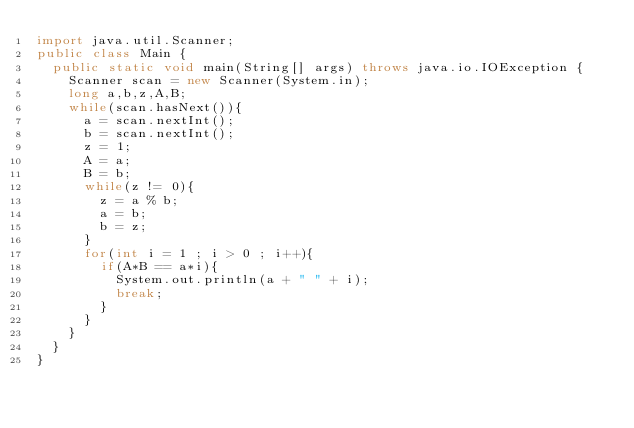<code> <loc_0><loc_0><loc_500><loc_500><_Java_>import java.util.Scanner;
public class Main {
	public static void main(String[] args) throws java.io.IOException {
		Scanner scan = new Scanner(System.in);
		long a,b,z,A,B;
		while(scan.hasNext()){
			a = scan.nextInt();
			b = scan.nextInt();
			z = 1;
			A = a;
			B = b;
			while(z != 0){
				z = a % b;
				a = b;
				b = z;
			}
			for(int i = 1 ; i > 0 ; i++){
				if(A*B == a*i){
					System.out.println(a + " " + i);
					break;
				}
			}
		}
	}
}</code> 